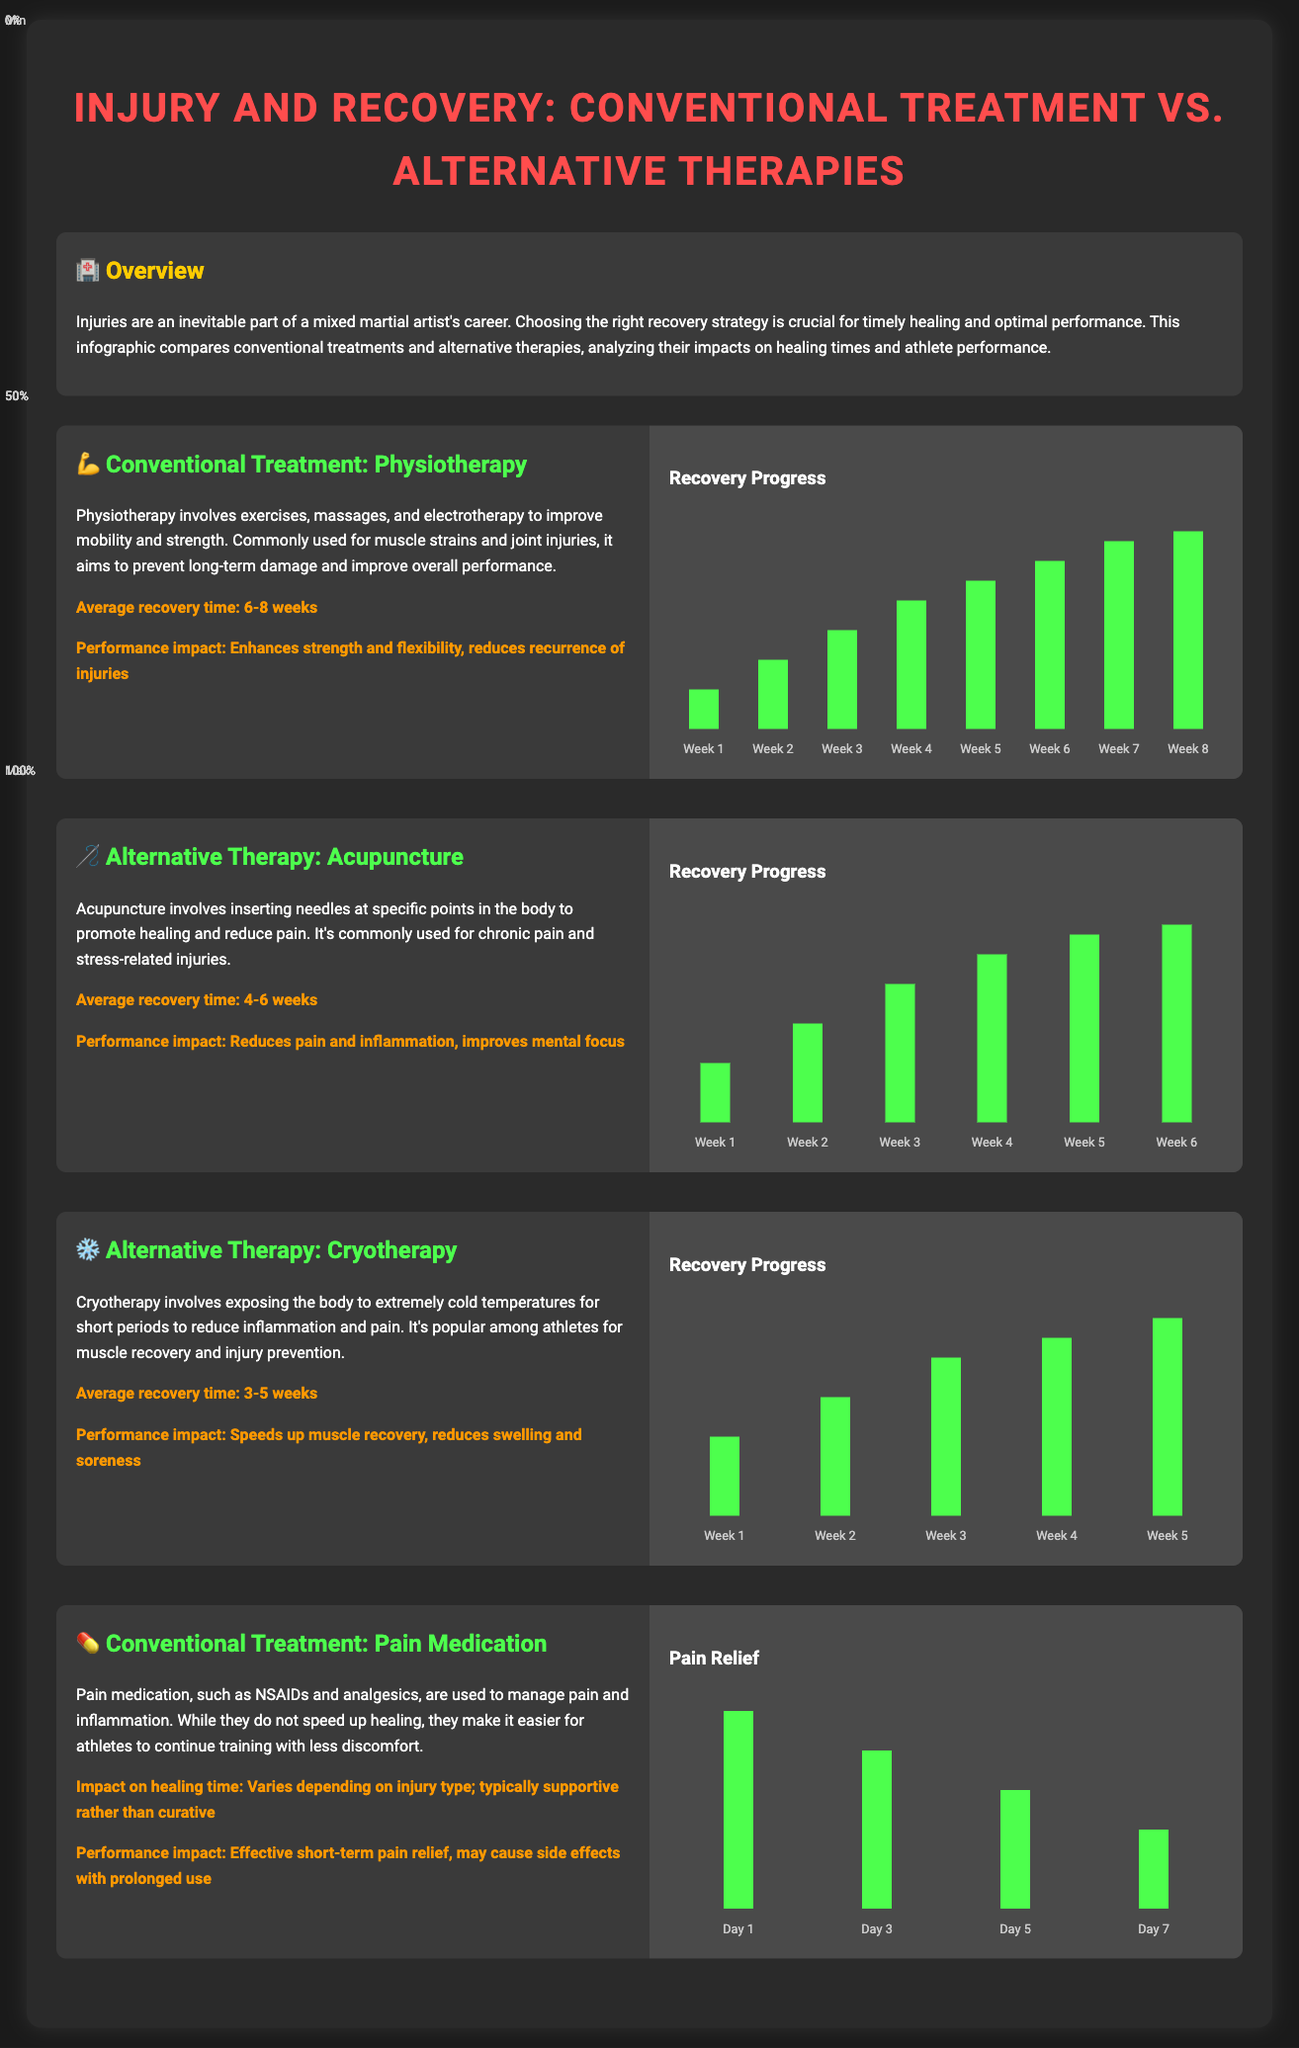What is the average recovery time for physiotherapy? The average recovery time for physiotherapy is stated as 6-8 weeks in the document.
Answer: 6-8 weeks What performance impact does acupuncture have? The document mentions that acupuncture reduces pain and inflammation and improves mental focus as its performance impact.
Answer: Reduces pain and inflammation, improves mental focus How long does cryotherapy typically take for recovery? The average recovery time for cryotherapy is mentioned as 3-5 weeks.
Answer: 3-5 weeks Which treatment has the longest average recovery time? By comparing the average recovery times listed for each treatment, physiotherapy has the longest recovery time of 6-8 weeks.
Answer: Physiotherapy What is the maximum pain relief reported on Day 1 for pain medication? The document provides that the maximum pain relief on Day 1 is indicated as 100%.
Answer: 100% Which therapy shows a recovery progress of 100% by week 5? The document states that cryotherapy shows a recovery progress of 100% by week 5.
Answer: Cryotherapy What is the primary goal of physiotherapy? The document outlines that the primary goal of physiotherapy is to improve mobility and strength.
Answer: Improve mobility and strength Which treatment has a recovery time listed as supportive rather than curative? The document specifies that pain medication has an impact on healing time that is supportive rather than curative.
Answer: Pain medication What is the common use for acupuncture? According to the document, acupuncture is commonly used for chronic pain and stress-related injuries.
Answer: Chronic pain and stress-related injuries 